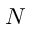Convert formula to latex. <formula><loc_0><loc_0><loc_500><loc_500>N</formula> 